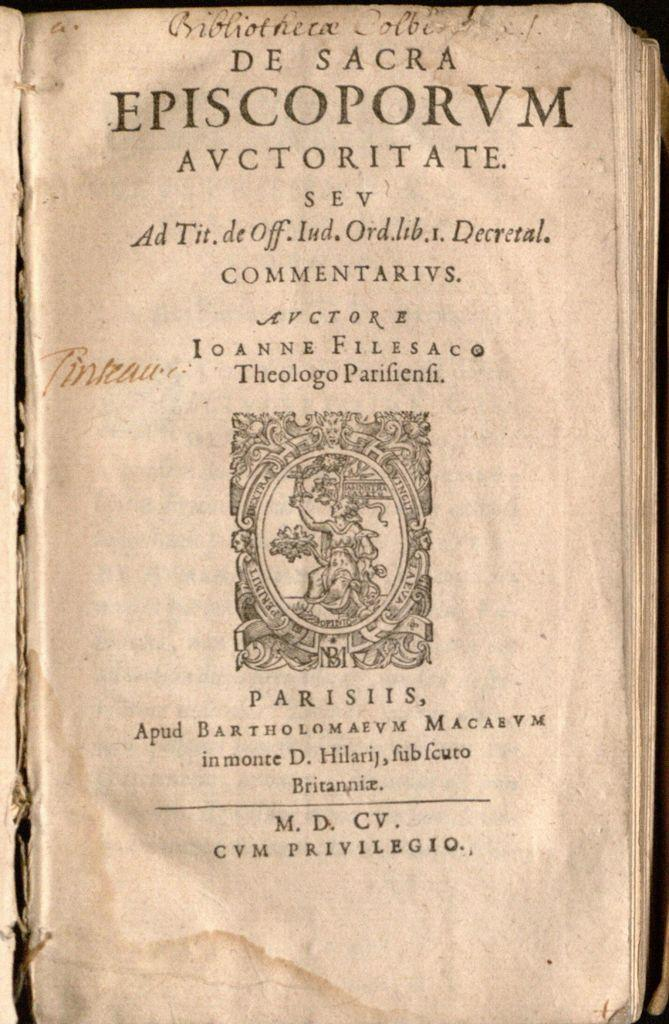<image>
Give a short and clear explanation of the subsequent image. A page from De Sacra Episcoporvm Avctoritate has a frayed binding. 